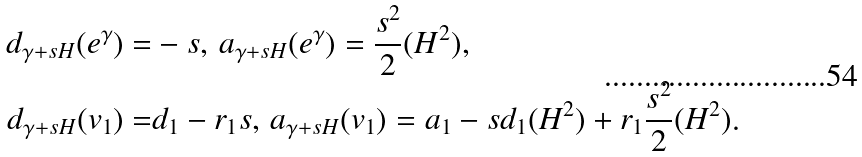Convert formula to latex. <formula><loc_0><loc_0><loc_500><loc_500>d _ { \gamma + s H } ( e ^ { \gamma } ) = & - s , \, a _ { \gamma + s H } ( e ^ { \gamma } ) = \frac { s ^ { 2 } } { 2 } ( H ^ { 2 } ) , \\ d _ { \gamma + s H } ( v _ { 1 } ) = & d _ { 1 } - r _ { 1 } s , \, a _ { \gamma + s H } ( v _ { 1 } ) = a _ { 1 } - s d _ { 1 } ( H ^ { 2 } ) + r _ { 1 } \frac { s ^ { 2 } } { 2 } ( H ^ { 2 } ) .</formula> 